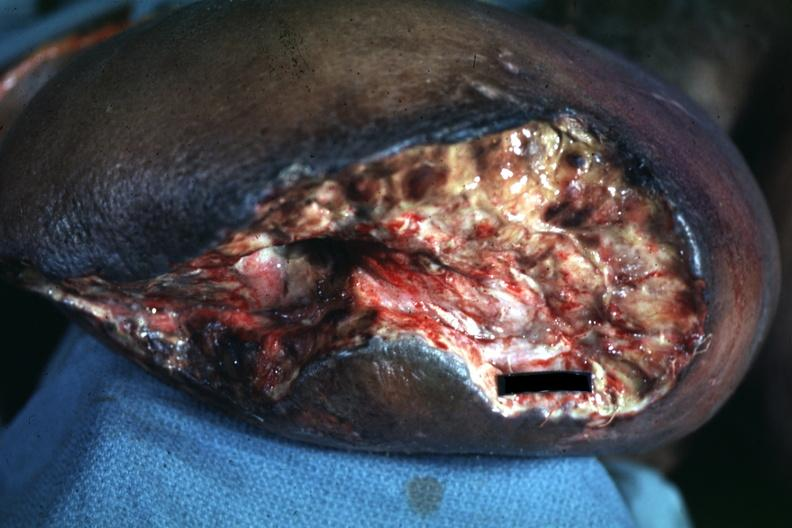what does this image show?
Answer the question using a single word or phrase. Open nasty looking wound appears to be mid thigh 